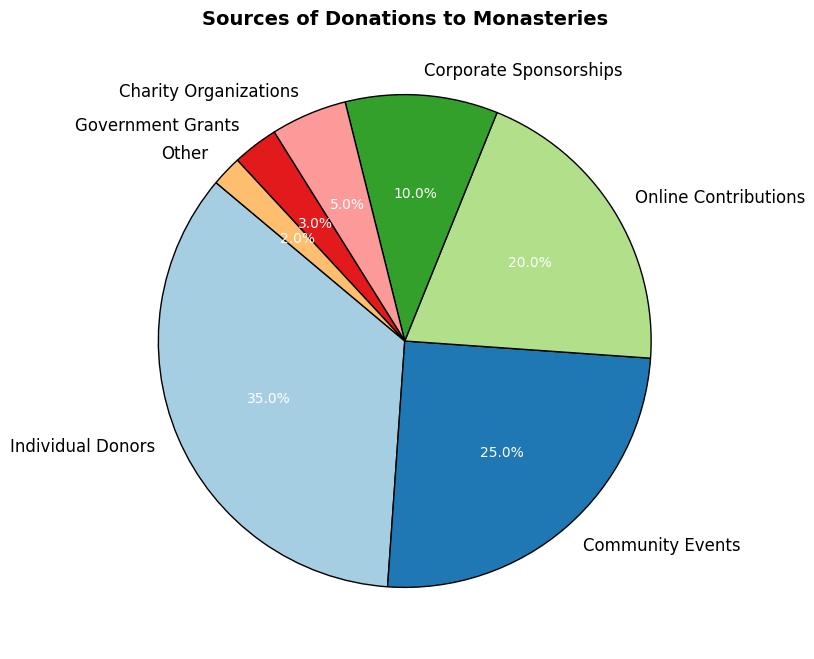Which source contributes the highest percentage to donations? By observing the sizes of the wedges in the pie chart, the wedge representing Individual Donors is the largest, indicating it has the highest percentage.
Answer: Individual Donors Which source has the second-highest contribution to donations? Comparing the wedges, the wedge for Community Events is the second largest after Individual Donors.
Answer: Community Events What is the combined percentage contribution of Corporate Sponsorships and Charity Organizations? The wedge for Corporate Sponsorships is 10% and for Charity Organizations is 5%. Adding them together gives 10% + 5% = 15%.
Answer: 15% Are Online Contributions greater than Government Grants? The wedge for Online Contributions is 20%, while the wedge for Government Grants is 3%. Since 20% is greater than 3%, Online Contributions are greater.
Answer: Yes What is the smallest source of donations? By examining the wedges, the smallest one represents the 'Other' category, indicating it is the smallest source.
Answer: Other How much larger is the contribution of Individual Donors compared to Government Grants? The Individual Donors contribute 35%, and Government Grants contribute 3%. The difference is 35% - 3% = 32%.
Answer: 32% How do the combined contributions of Community Events and Online Contributions compare to Individual Donors? Community Events contribute 25% and Online Contributions contribute 20%, together they contribute 25% + 20% = 45%. Comparing this to Individual Donors who contribute 35%, 45% is larger than 35%.
Answer: Greater What percentage of total donations comes from sources other than Individual Donors? If Individual Donors contribute 35%, the rest contribute 100% - 35% = 65%.
Answer: 65% Is the contribution from Charity Organizations more or less than half of the contribution from Corporate Sponsorships? Charity Organizations contribute 5% and Corporate Sponsorships contribute 10%. Half of Corporate Sponsorships (10%) is 5%, which is equal to the contribution from Charity Organizations.
Answer: Equal 